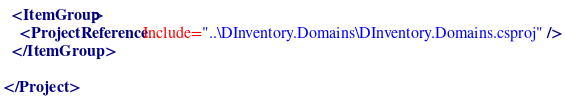Convert code to text. <code><loc_0><loc_0><loc_500><loc_500><_XML_>
  <ItemGroup>
    <ProjectReference Include="..\DInventory.Domains\DInventory.Domains.csproj" />
  </ItemGroup>

</Project>
</code> 